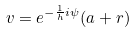Convert formula to latex. <formula><loc_0><loc_0><loc_500><loc_500>v = e ^ { - \frac { 1 } { h } i \psi } ( a + r )</formula> 